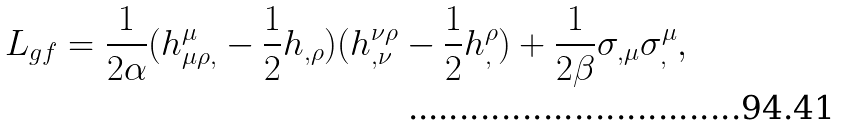Convert formula to latex. <formula><loc_0><loc_0><loc_500><loc_500>L _ { g f } = \frac { 1 } { 2 \alpha } ( h _ { \mu \rho , } ^ { \mu } - \frac { 1 } { 2 } h _ { , \rho } ) ( h _ { , \nu } ^ { \nu \rho } - \frac { 1 } { 2 } h _ { , } ^ { \rho } ) + \frac { 1 } { 2 \beta } \sigma _ { , \mu } \sigma _ { , } ^ { \mu } ,</formula> 